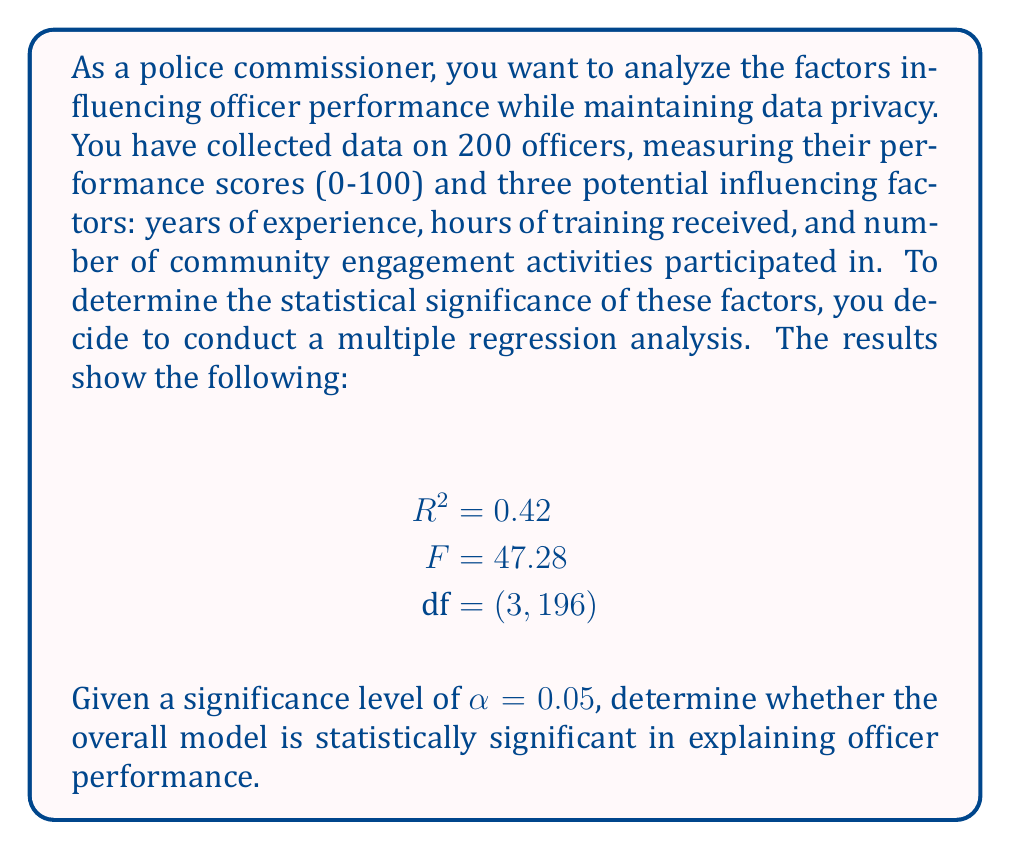Solve this math problem. To determine if the overall model is statistically significant, we need to compare the calculated F-statistic to the critical F-value. Here's the step-by-step process:

1. Identify the test statistic:
   The F-statistic is given as 47.28.

2. Determine the degrees of freedom:
   $\text{df}_{\text{numerator}} = 3$ (number of predictors)
   $\text{df}_{\text{denominator}} = 196$ (sample size - number of predictors - 1)

3. Find the critical F-value:
   For $\alpha = 0.05$, $\text{df}_{\text{numerator}} = 3$, and $\text{df}_{\text{denominator}} = 196$, we can use an F-distribution table or statistical software to find the critical F-value.
   $F_{\text{critical}} \approx 2.65$

4. Compare the F-statistic to the critical F-value:
   Since $F_{\text{calculated}} = 47.28 > F_{\text{critical}} \approx 2.65$, we reject the null hypothesis.

5. Interpret the results:
   The overall model is statistically significant, meaning that at least one of the predictor variables (years of experience, hours of training, or community engagement activities) has a significant effect on officer performance.

6. Additional interpretation:
   The $R^2$ value of 0.42 indicates that approximately 42% of the variance in officer performance can be explained by the three factors in the model.

It's important to note that while this analysis provides valuable insights, as a privacy-conscious police commissioner, you should ensure that individual officer data remains confidential and that only aggregated results are shared with relevant stakeholders.
Answer: The overall model is statistically significant (F(3, 196) = 47.28, p < 0.05), indicating that at least one of the factors (years of experience, hours of training, or community engagement activities) has a significant influence on officer performance. 